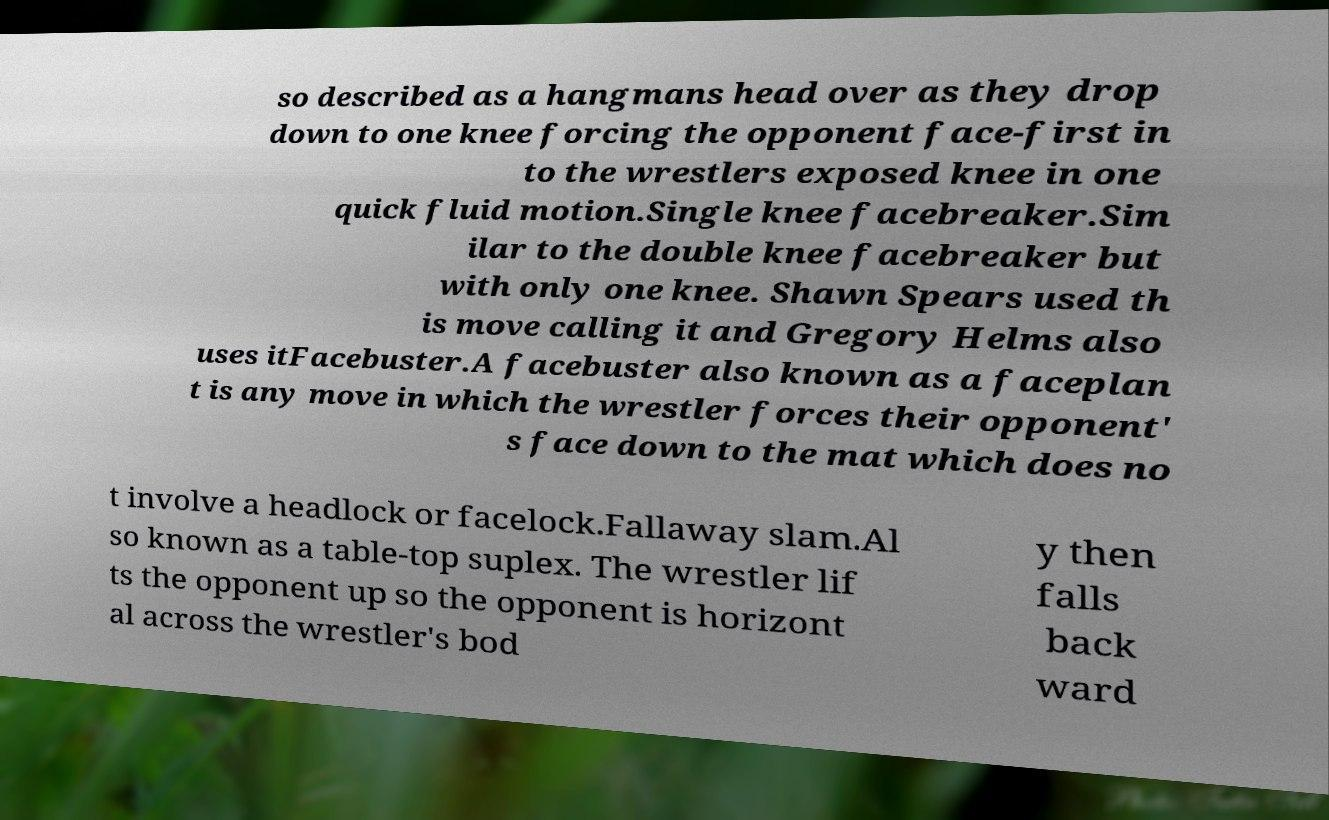Please read and relay the text visible in this image. What does it say? so described as a hangmans head over as they drop down to one knee forcing the opponent face-first in to the wrestlers exposed knee in one quick fluid motion.Single knee facebreaker.Sim ilar to the double knee facebreaker but with only one knee. Shawn Spears used th is move calling it and Gregory Helms also uses itFacebuster.A facebuster also known as a faceplan t is any move in which the wrestler forces their opponent' s face down to the mat which does no t involve a headlock or facelock.Fallaway slam.Al so known as a table-top suplex. The wrestler lif ts the opponent up so the opponent is horizont al across the wrestler's bod y then falls back ward 